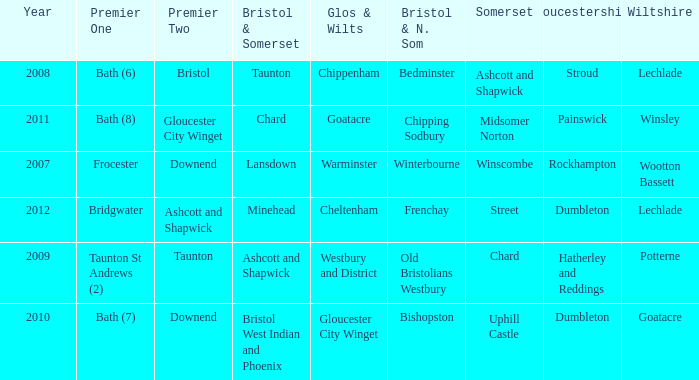What is the somerset for the  year 2009? Chard. 